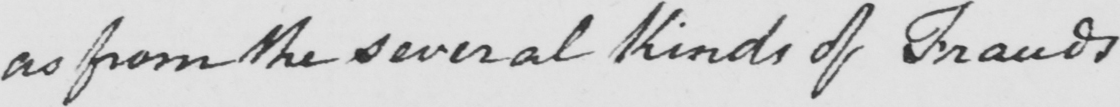What text is written in this handwritten line? as from the several Kinds of Frauds . 